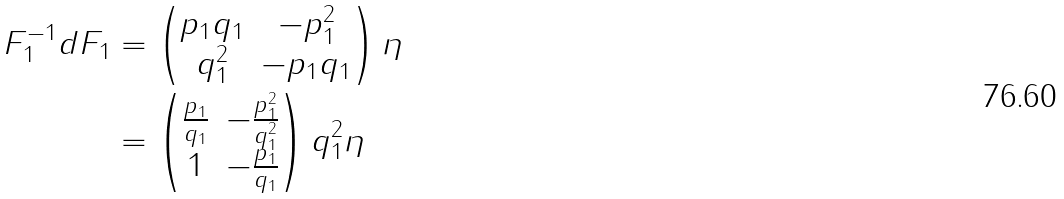<formula> <loc_0><loc_0><loc_500><loc_500>F _ { 1 } ^ { - 1 } d F _ { 1 } & = \begin{pmatrix} p _ { 1 } q _ { 1 } & - p _ { 1 } ^ { 2 } \\ q _ { 1 } ^ { 2 } & - p _ { 1 } q _ { 1 } \end{pmatrix} \eta \\ & = \begin{pmatrix} \frac { p _ { 1 } } { q _ { 1 } } & - \frac { p _ { 1 } ^ { 2 } } { q _ { 1 } ^ { 2 } } \\ 1 & - \frac { p _ { 1 } } { q _ { 1 } } \end{pmatrix} q _ { 1 } ^ { 2 } \eta</formula> 